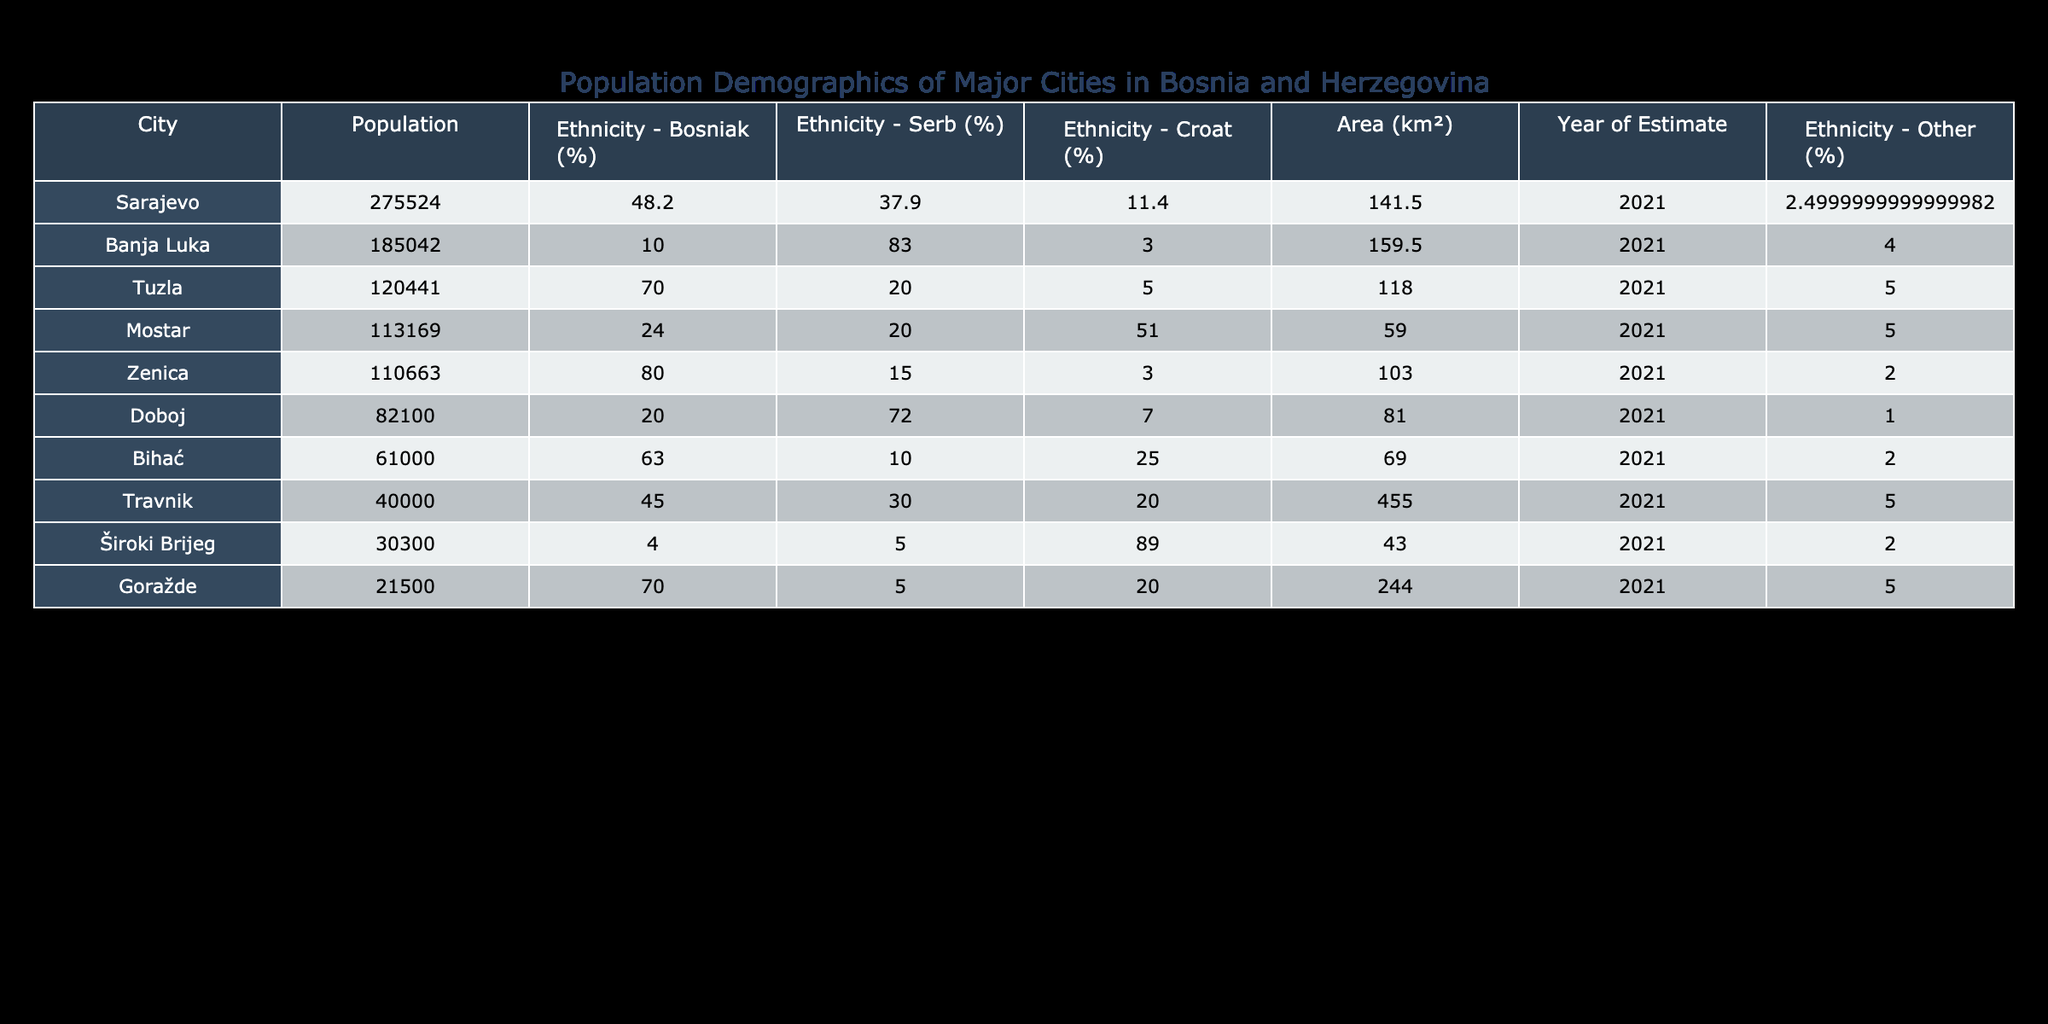What is the population of Sarajevo? The table shows that the population of Sarajevo is listed as 275,524.
Answer: 275524 Which city has the highest percentage of Bosniaks? Looking at the Ethnicity - Bosniak (%) column, Zenica has the highest percentage at 80.0%.
Answer: 80.0 What is the average population of the cities listed? To find the average population, sum the populations of all cities: (275524 + 185042 + 120441 + 110663 + 113169 + 82100 + 61000 + 30300 + 40000 + 21500) =  650,739. Then divide by the number of cities (10), which gives an average of 65,073.9.
Answer: 65073.9 Is the population of Banja Luka greater than 200,000? The population of Banja Luka is 185,042, which is less than 200,000, so the statement is false.
Answer: False Which city has the largest area? The Area (km²) column shows that Travnik has the largest area at 455.0 km².
Answer: 455.0 What is the total percentage of Serbs in Tuzla and Doboj combined? For Tuzla, the percentage of Serbs is 20.0% and for Doboj, it's 72.0%. Adding these gives 20.0% + 72.0% = 92.0%.
Answer: 92.0 Is the percentage of Croats in Mostar higher than in Zenica? In Mostar, the percentage of Croats is 51.0%, while in Zenica, it is 3.0%, thus Mostar has a higher percentage than Zenica.
Answer: True What percentage of the population in Goražde identifies as other ethnicities? Goražde has 70.0% Bosniaks and 5.0% Serbs, and 20.0% Croats. Therefore, the percentage of 'Other' is 100% - (70.0% + 5.0% + 20.0%) = 5.0%.
Answer: 5.0 Which city has the least population? Based on the Population column, Široki Brijeg has the least population at 30,300.
Answer: 30300 What is the difference in population between Sarajevo and Bihać? The population of Sarajevo is 275,524 and Bihać is 61,000. The difference is 275,524 - 61,000 = 214,524.
Answer: 214524 